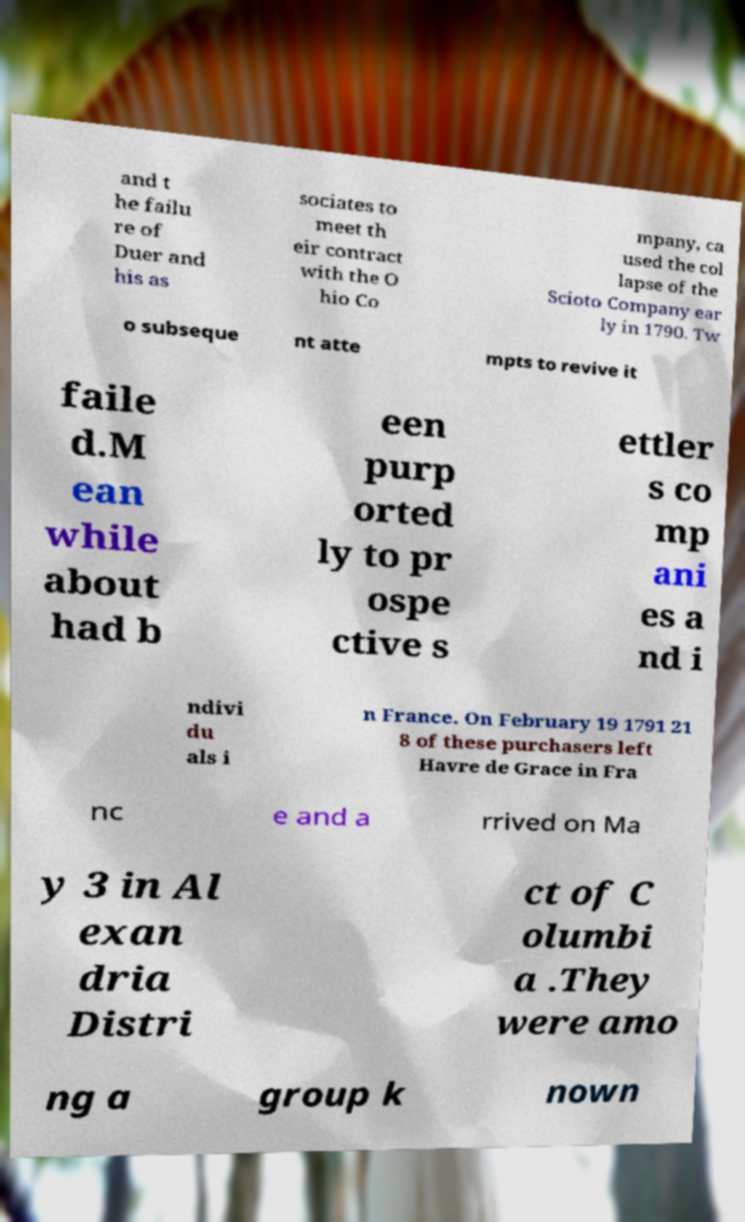For documentation purposes, I need the text within this image transcribed. Could you provide that? and t he failu re of Duer and his as sociates to meet th eir contract with the O hio Co mpany, ca used the col lapse of the Scioto Company ear ly in 1790. Tw o subseque nt atte mpts to revive it faile d.M ean while about had b een purp orted ly to pr ospe ctive s ettler s co mp ani es a nd i ndivi du als i n France. On February 19 1791 21 8 of these purchasers left Havre de Grace in Fra nc e and a rrived on Ma y 3 in Al exan dria Distri ct of C olumbi a .They were amo ng a group k nown 